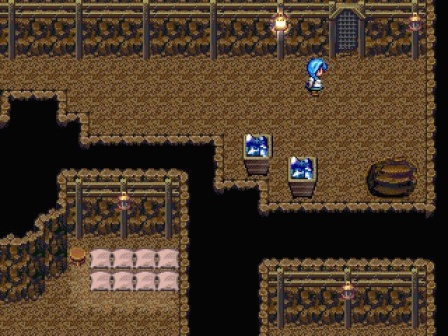Could the bed in the bottom left corner indicate a safe point in the game? How does it impact gameplay? Yes, the bed likely represents a safe or save point within the game, where players can save their progress or possibly recover health. This adds a strategic component to gameplay, encouraging careful exploration and management of resources to reach these points safely. 